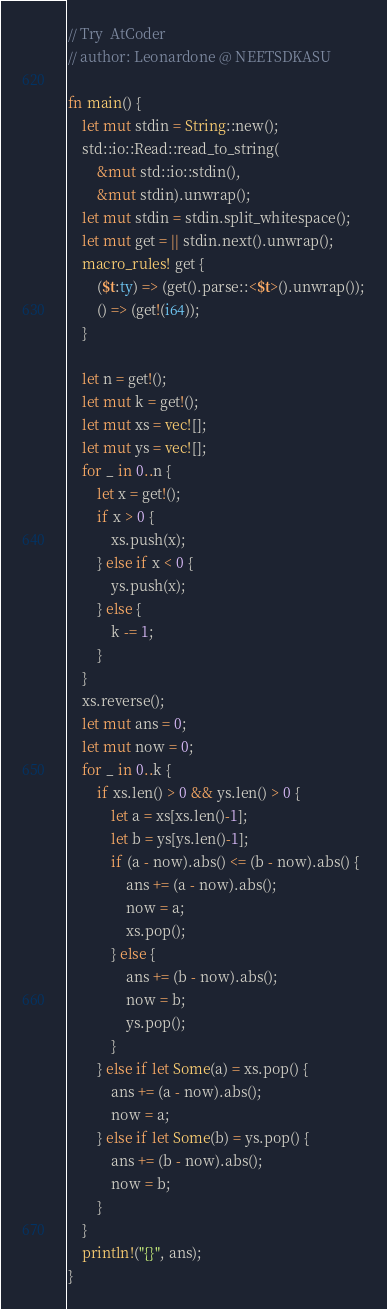Convert code to text. <code><loc_0><loc_0><loc_500><loc_500><_Rust_>// Try  AtCoder
// author: Leonardone @ NEETSDKASU

fn main() {
	let mut stdin = String::new();
    std::io::Read::read_to_string(
    	&mut std::io::stdin(),
        &mut stdin).unwrap();
	let mut stdin = stdin.split_whitespace();
    let mut get = || stdin.next().unwrap();
    macro_rules! get {
    	($t:ty) => (get().parse::<$t>().unwrap());
        () => (get!(i64));
    }
    
    let n = get!();
    let mut k = get!();
    let mut xs = vec![];
    let mut ys = vec![];
    for _ in 0..n {
    	let x = get!();
        if x > 0 {
        	xs.push(x);
        } else if x < 0 {
        	ys.push(x);
        } else {
        	k -= 1;
        }
    }
    xs.reverse();
    let mut ans = 0;
    let mut now = 0;
    for _ in 0..k {
    	if xs.len() > 0 && ys.len() > 0 {
        	let a = xs[xs.len()-1];
        	let b = ys[ys.len()-1];
            if (a - now).abs() <= (b - now).abs() {
            	ans += (a - now).abs();
            	now = a;
                xs.pop();
            } else {
            	ans += (b - now).abs();
            	now = b;
                ys.pop();
            }
        } else if let Some(a) = xs.pop() {
        	ans += (a - now).abs();
            now = a;
        } else if let Some(b) = ys.pop() {
        	ans += (b - now).abs();
            now = b;
        }
    }
    println!("{}", ans);
}</code> 